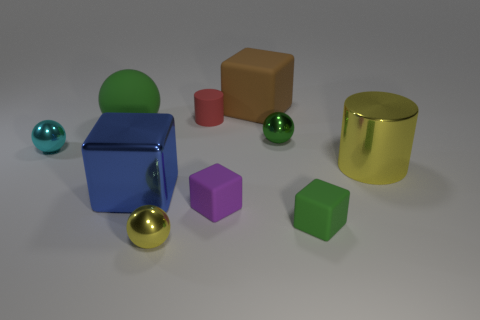What is the size of the other green object that is the same shape as the large green object?
Keep it short and to the point. Small. What is the color of the other large thing that is the same shape as the blue thing?
Your response must be concise. Brown. There is a tiny shiny object that is the same color as the rubber ball; what is its shape?
Your answer should be very brief. Sphere. What number of other yellow metal cylinders have the same size as the yellow cylinder?
Offer a very short reply. 0. What number of green objects are behind the big blue cube?
Provide a short and direct response. 2. The cube left of the tiny shiny thing that is in front of the tiny cyan metallic thing is made of what material?
Your answer should be compact. Metal. Is there a tiny rubber cube that has the same color as the large ball?
Provide a short and direct response. Yes. The cylinder that is made of the same material as the tiny yellow ball is what size?
Provide a succinct answer. Large. Are there any other things that have the same color as the small cylinder?
Provide a short and direct response. No. What is the color of the rubber thing that is on the right side of the large brown object?
Ensure brevity in your answer.  Green. 